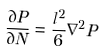<formula> <loc_0><loc_0><loc_500><loc_500>\frac { \partial P } { \partial N } = \frac { l ^ { 2 } } { 6 } \nabla ^ { 2 } P</formula> 